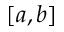Convert formula to latex. <formula><loc_0><loc_0><loc_500><loc_500>[ a , b ]</formula> 